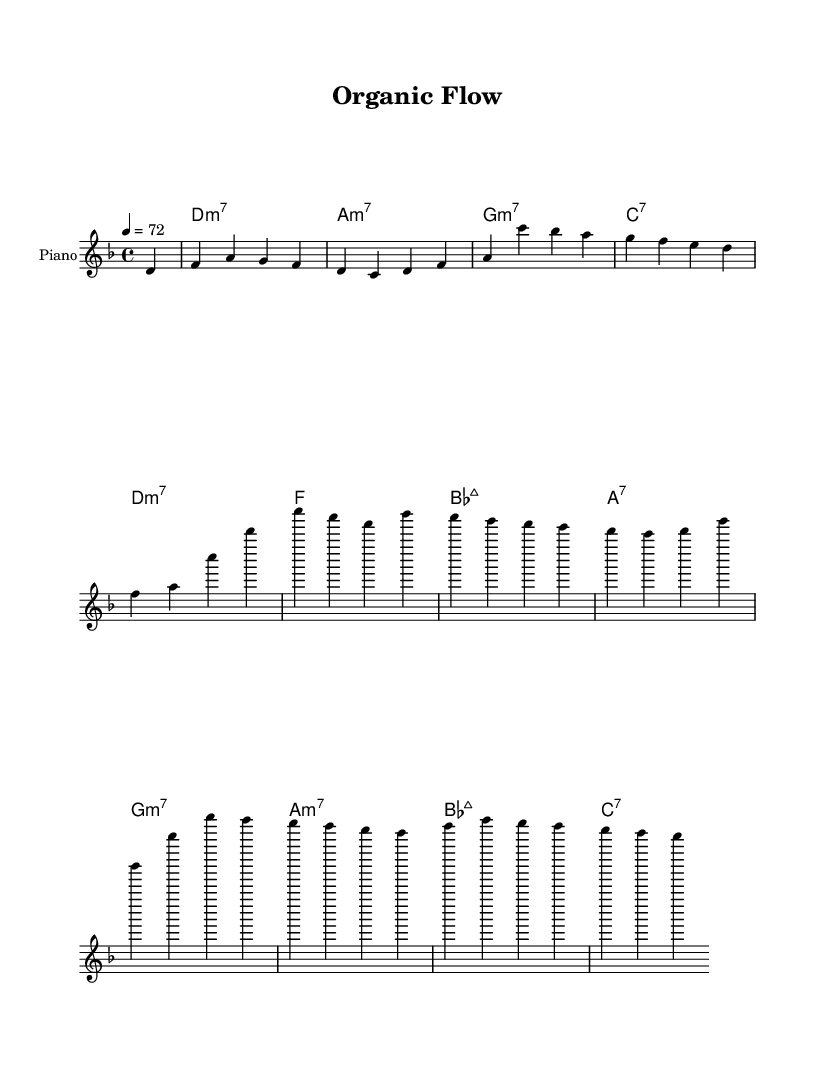What is the key signature of this music? The key signature is indicated at the beginning of the staff, which shows one flat. In the context of music, one flat corresponds to the key of D minor.
Answer: D minor What is the time signature of this music? The time signature is displayed at the beginning of the staff. It reads 4/4, which means there are four beats in each measure, and the quarter note gets one beat.
Answer: 4/4 What is the tempo marking of this music? The tempo marking is found after the time signature and states a speed of "4 = 72," which signifies that the quarter note should be played at a rate of 72 beats per minute.
Answer: 72 How many measures are present in the melody? By counting the bar lines in the rendered sheet music, we find that there are a total of 8 measures. Each division of the staff denotes a measure, and the total is determined by how many times the measure lines appear.
Answer: 8 What is the first chord played in this piece? The chord progression starts after the partial bar and is indicated underneath the melody. The first full chord is labeled as D minor 7.
Answer: D minor 7 Which scale degree does the melody start on? Observing the first note in the melody, it begins with D, which serves as the tonic in the context of D minor. The tonic is the first scale degree and thus establishes the root of the melody.
Answer: D What type of harmony is predominantly used in this piece? Examining the chord names, we can note that seventh chords like minor 7 and major 7 are frequently utilized, contributing to a smooth and soulful character typical of neo-soul music.
Answer: Seventh chords 